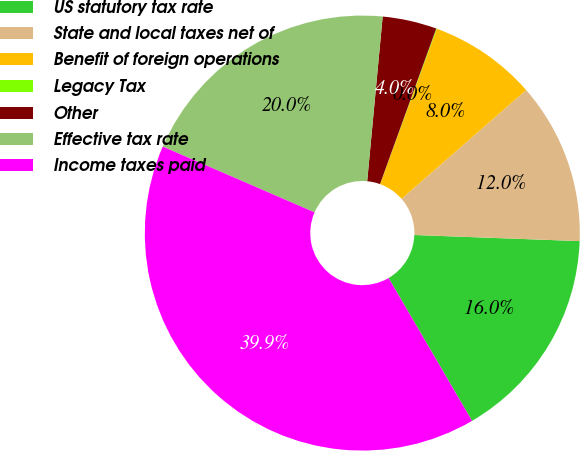Convert chart. <chart><loc_0><loc_0><loc_500><loc_500><pie_chart><fcel>US statutory tax rate<fcel>State and local taxes net of<fcel>Benefit of foreign operations<fcel>Legacy Tax<fcel>Other<fcel>Effective tax rate<fcel>Income taxes paid<nl><fcel>16.0%<fcel>12.01%<fcel>8.02%<fcel>0.04%<fcel>4.03%<fcel>19.99%<fcel>39.93%<nl></chart> 